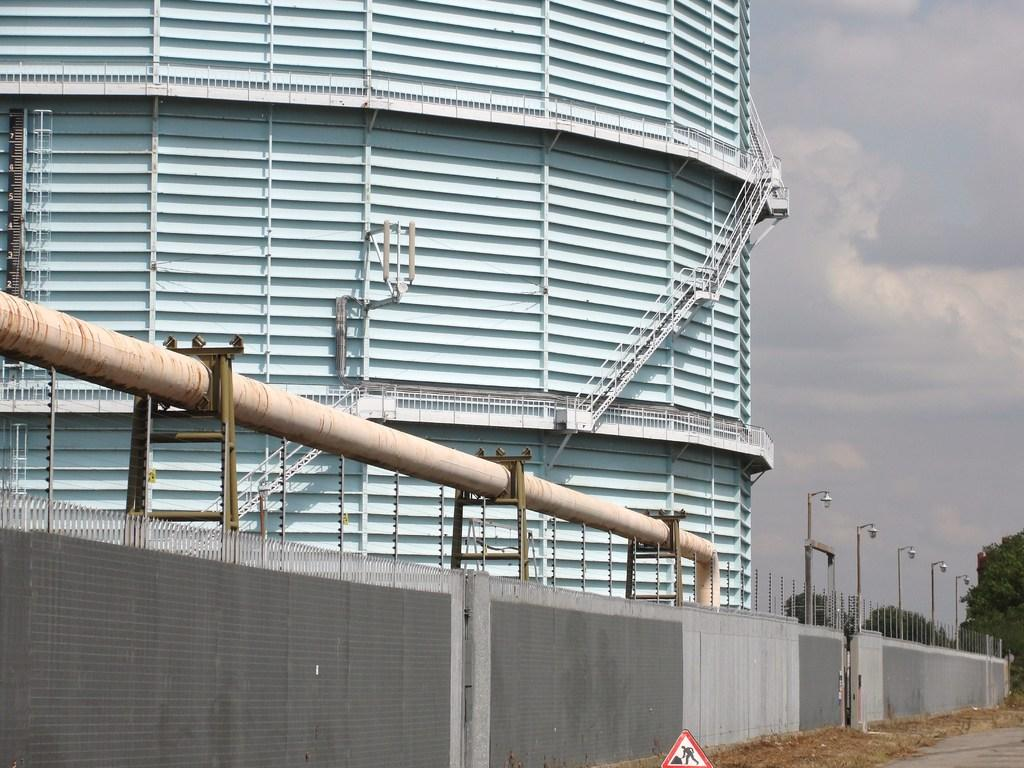What type of structure is visible in the image? There is a building in the image. What feature can be seen near the building? There is a railing in the image. What architectural element is present in the image? There is a staircase in the image. What other object can be seen in the image? There is a pipeline in the image. What is the immediate surrounding of the building made of? There is a wall in the image. What can be seen in the background of the image? There are trees and the sky visible in the background of the image. What type of board is being used to make a decision in the image? There is no board or decision-making process depicted in the image. What substance can be seen dripping from the pipeline in the image? The image does not show any substance dripping from the pipeline. 